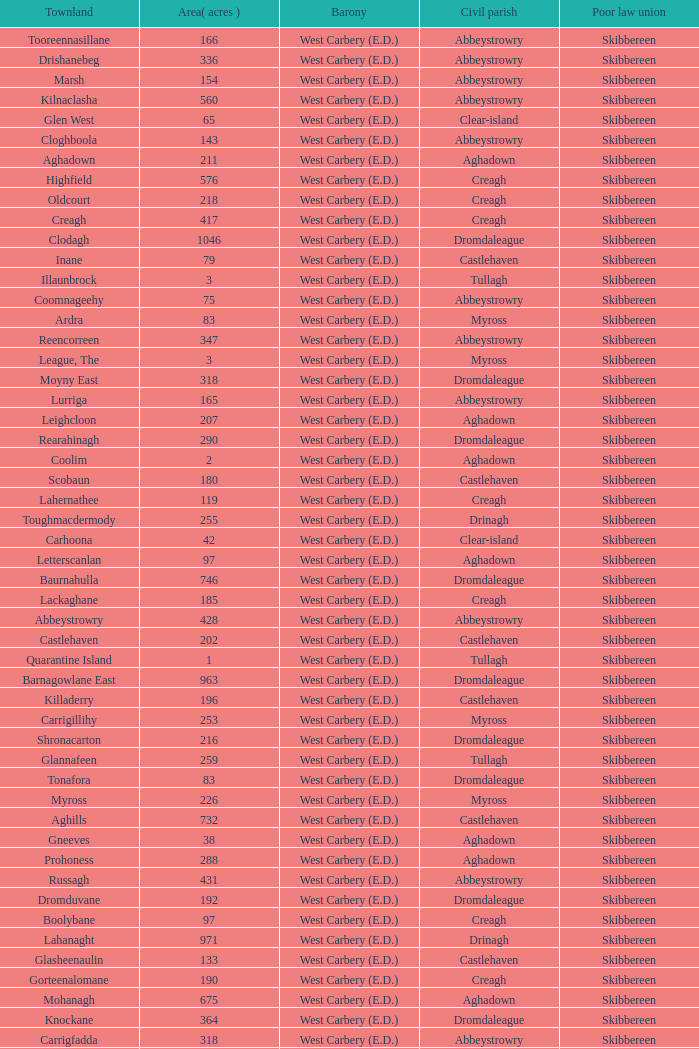What is the greatest area when the Poor Law Union is Skibbereen and the Civil Parish is Tullagh? 796.0. 